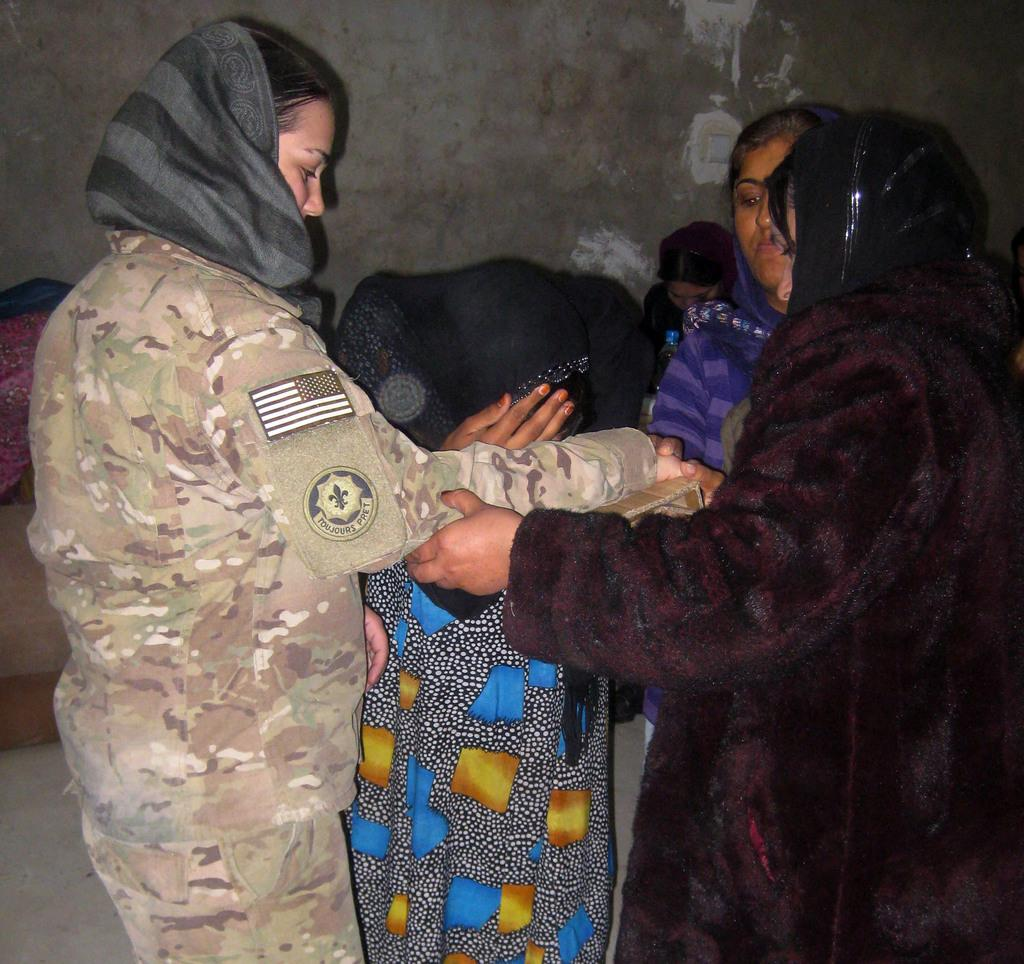What can be seen in the image? There are people standing in the image. What is visible in the background of the image? There is a wall, clothes, and a table in the background of the image. What part of the image shows the ground? The floor is visible at the bottom of the image. Can you see any horses or the seashore in the image? No, there are no horses or seashore present in the image. Is the person's aunt visible in the image? There is no information about the person's aunt in the image or the provided facts. 